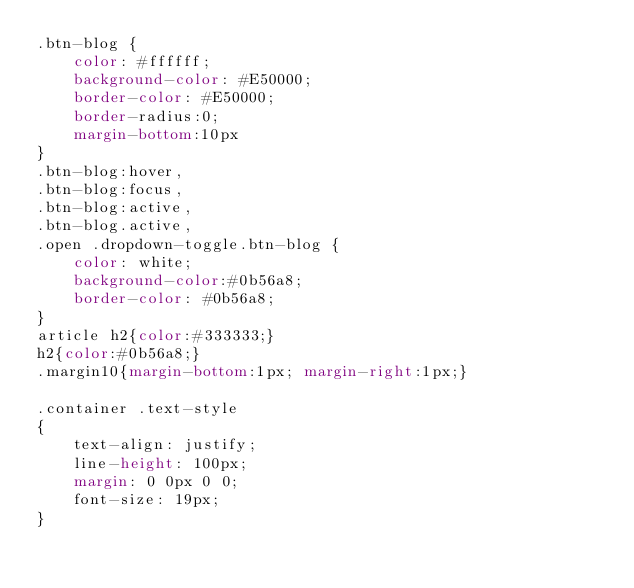<code> <loc_0><loc_0><loc_500><loc_500><_CSS_>.btn-blog {
    color: #ffffff;
    background-color: #E50000;
    border-color: #E50000;
    border-radius:0;
    margin-bottom:10px
}
.btn-blog:hover,
.btn-blog:focus,
.btn-blog:active,
.btn-blog.active,
.open .dropdown-toggle.btn-blog {
    color: white;
    background-color:#0b56a8;
    border-color: #0b56a8;
}
article h2{color:#333333;}
h2{color:#0b56a8;}
.margin10{margin-bottom:1px; margin-right:1px;}

.container .text-style
{
    text-align: justify;
    line-height: 100px;
    margin: 0 0px 0 0;
    font-size: 19px;
}
</code> 